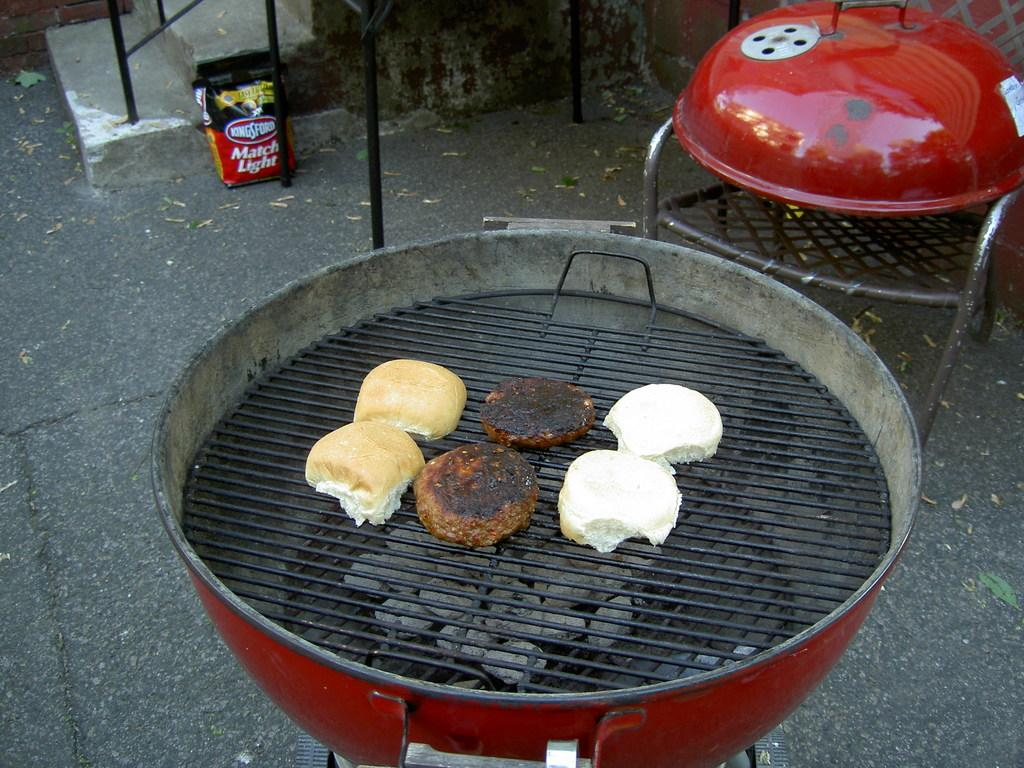Provide a one-sentence caption for the provided image. A BBQ grill with buns and burgers on it and a bag of Kingsford match light in the background. 